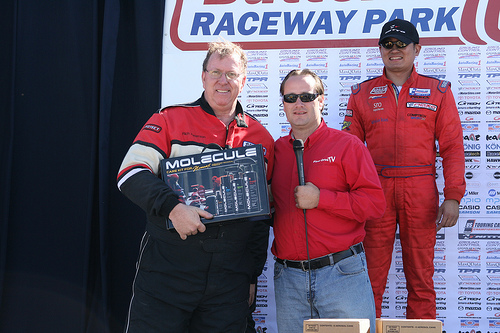<image>
Is the small man to the left of the big man? Yes. From this viewpoint, the small man is positioned to the left side relative to the big man. 